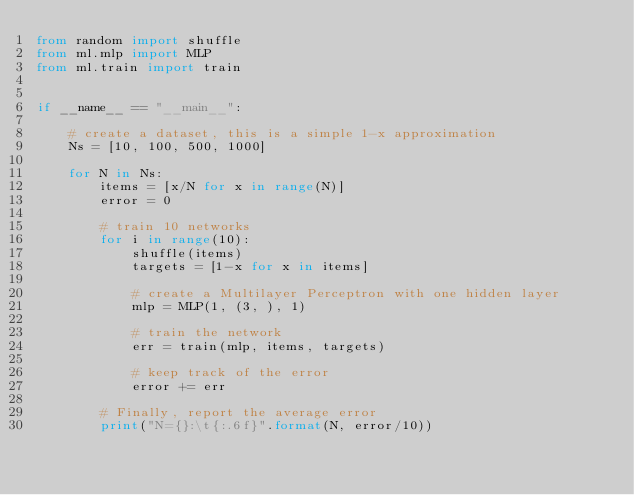<code> <loc_0><loc_0><loc_500><loc_500><_Python_>from random import shuffle
from ml.mlp import MLP
from ml.train import train


if __name__ == "__main__":

    # create a dataset, this is a simple 1-x approximation
    Ns = [10, 100, 500, 1000]

    for N in Ns:
        items = [x/N for x in range(N)]
        error = 0

        # train 10 networks
        for i in range(10):
            shuffle(items)
            targets = [1-x for x in items]

            # create a Multilayer Perceptron with one hidden layer
            mlp = MLP(1, (3, ), 1)

            # train the network
            err = train(mlp, items, targets)

            # keep track of the error
            error += err

        # Finally, report the average error
        print("N={}:\t{:.6f}".format(N, error/10))

</code> 